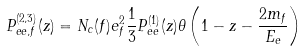<formula> <loc_0><loc_0><loc_500><loc_500>P _ { e e , f } ^ { ( 2 , 3 ) } ( z ) = N _ { c } ( f ) e _ { f } ^ { 2 } \frac { 1 } { 3 } P _ { e e } ^ { ( 1 ) } ( z ) \theta \left ( 1 - z - \frac { 2 m _ { f } } { E _ { e } } \right )</formula> 